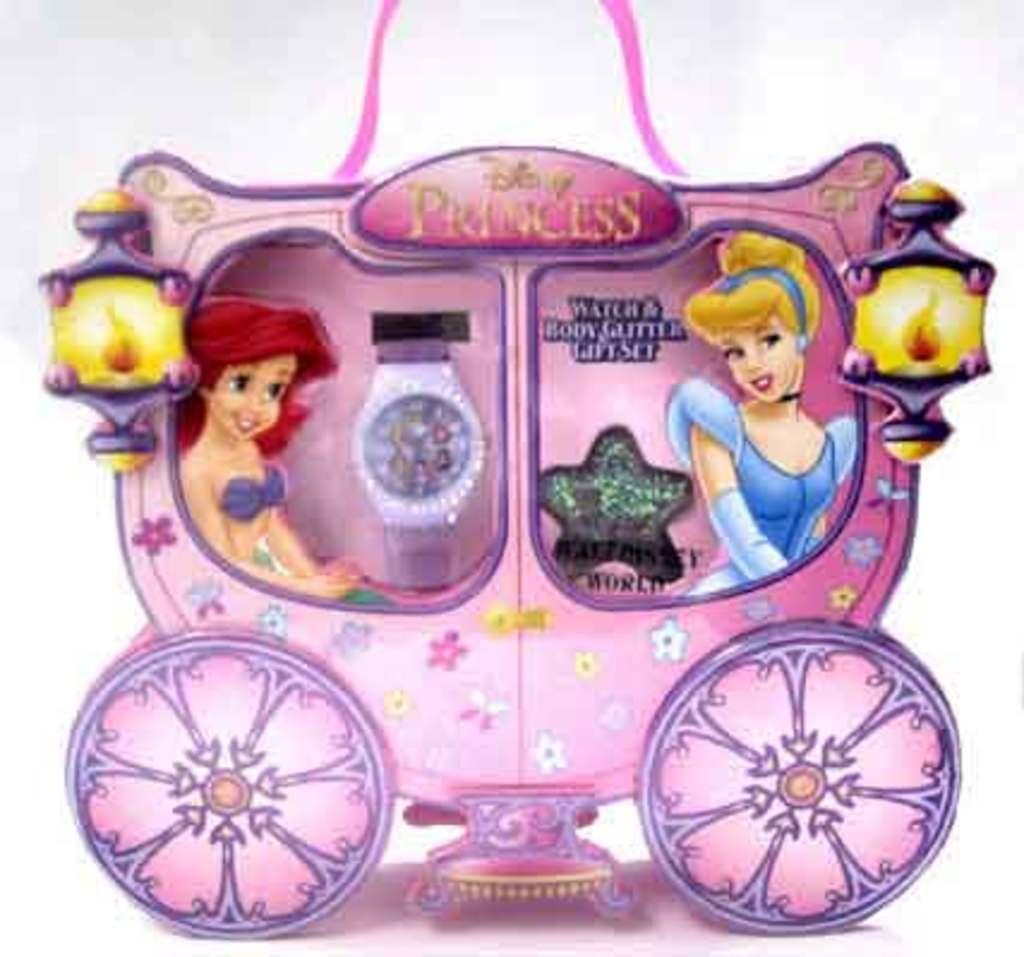Can you describe this image briefly? In the center of the image there is a vehicle and we can see a mermaid and a barbie sitting in the vehicle. There is a watch and lights. 